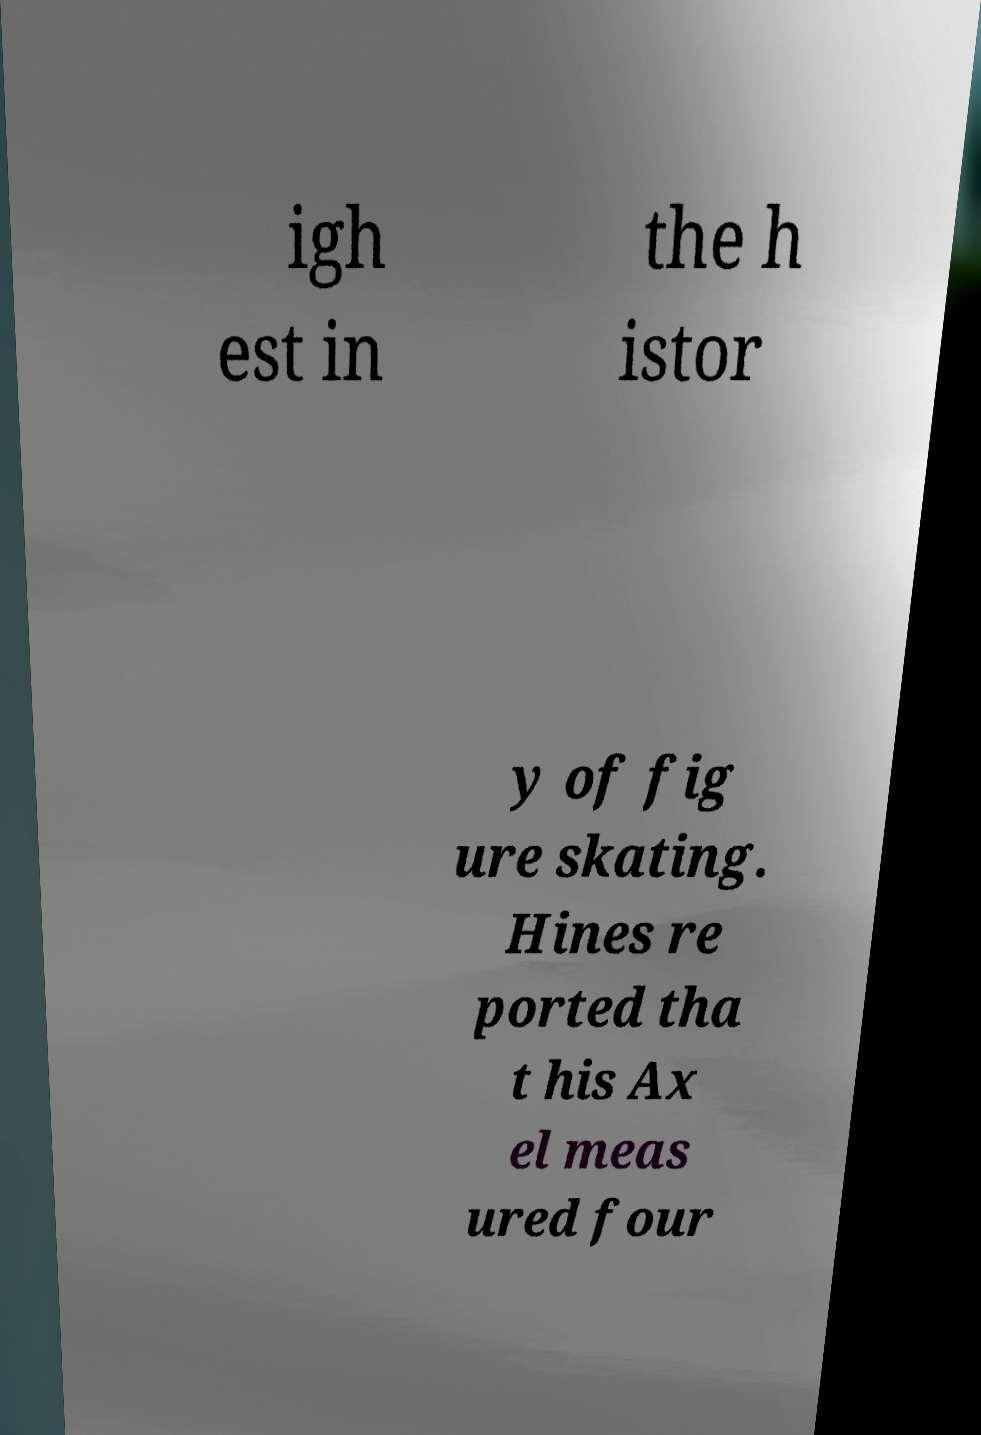Can you accurately transcribe the text from the provided image for me? igh est in the h istor y of fig ure skating. Hines re ported tha t his Ax el meas ured four 